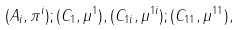Convert formula to latex. <formula><loc_0><loc_0><loc_500><loc_500>( A _ { i } , \pi ^ { i } ) ; ( C _ { 1 } , \mu ^ { 1 } ) , ( C _ { 1 i } , \mu ^ { 1 i } ) ; ( C _ { 1 1 } , \mu ^ { 1 1 } ) ,</formula> 